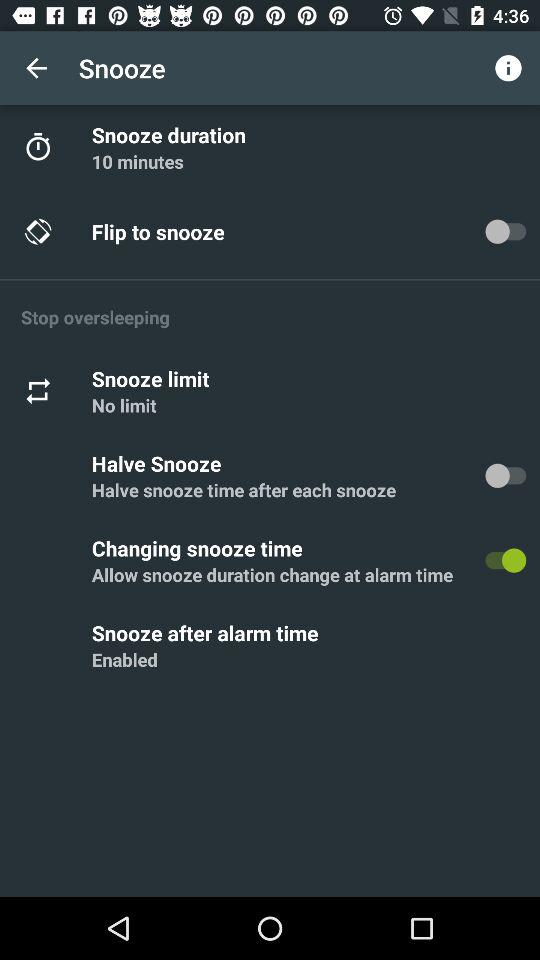What is the status of flip to snooze? The status is "off". 